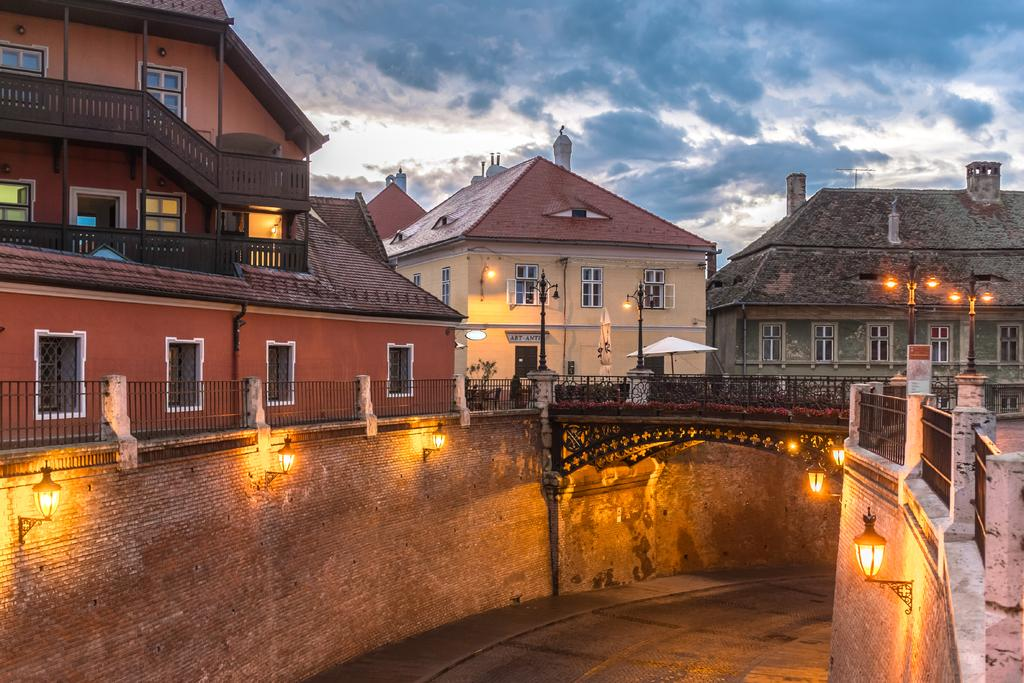What is the main subject of the image? The main subject of the image is a road. What else can be seen in the image besides the road? There are lights and buildings visible in the image. What is visible at the top of the image? The sky is visible at the top of the image. Can you tell me how many bags of popcorn are on the dock in the image? There is no dock or popcorn present in the image. What type of cork is used to seal the bottles in the image? There are no bottles or corks present in the image. 